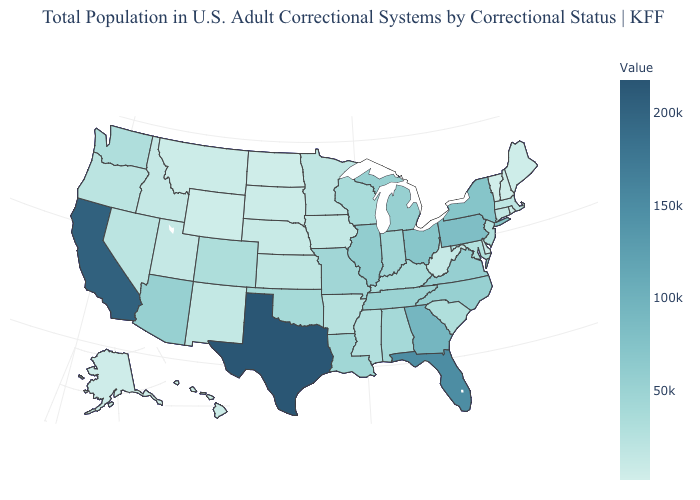Does Texas have the highest value in the South?
Quick response, please. Yes. Which states have the lowest value in the USA?
Be succinct. Vermont. Which states have the highest value in the USA?
Be succinct. Texas. Among the states that border Washington , does Idaho have the highest value?
Give a very brief answer. No. Does the map have missing data?
Answer briefly. No. Among the states that border Nevada , does California have the highest value?
Write a very short answer. Yes. Among the states that border Montana , does Idaho have the highest value?
Concise answer only. Yes. Does Louisiana have a higher value than Delaware?
Write a very short answer. Yes. Does Rhode Island have a higher value than Missouri?
Quick response, please. No. Is the legend a continuous bar?
Be succinct. Yes. 